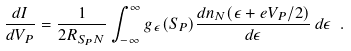<formula> <loc_0><loc_0><loc_500><loc_500>\frac { d I } { d V _ { P } } = \frac { 1 } { 2 R _ { S _ { P } N } } \int _ { - \infty } ^ { \infty } g _ { \epsilon } ( S _ { P } ) \frac { d n _ { N } ( \epsilon + e V _ { P } / 2 ) } { d \epsilon } \, d \epsilon \ .</formula> 